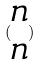<formula> <loc_0><loc_0><loc_500><loc_500>( \begin{matrix} n \\ n \end{matrix} )</formula> 